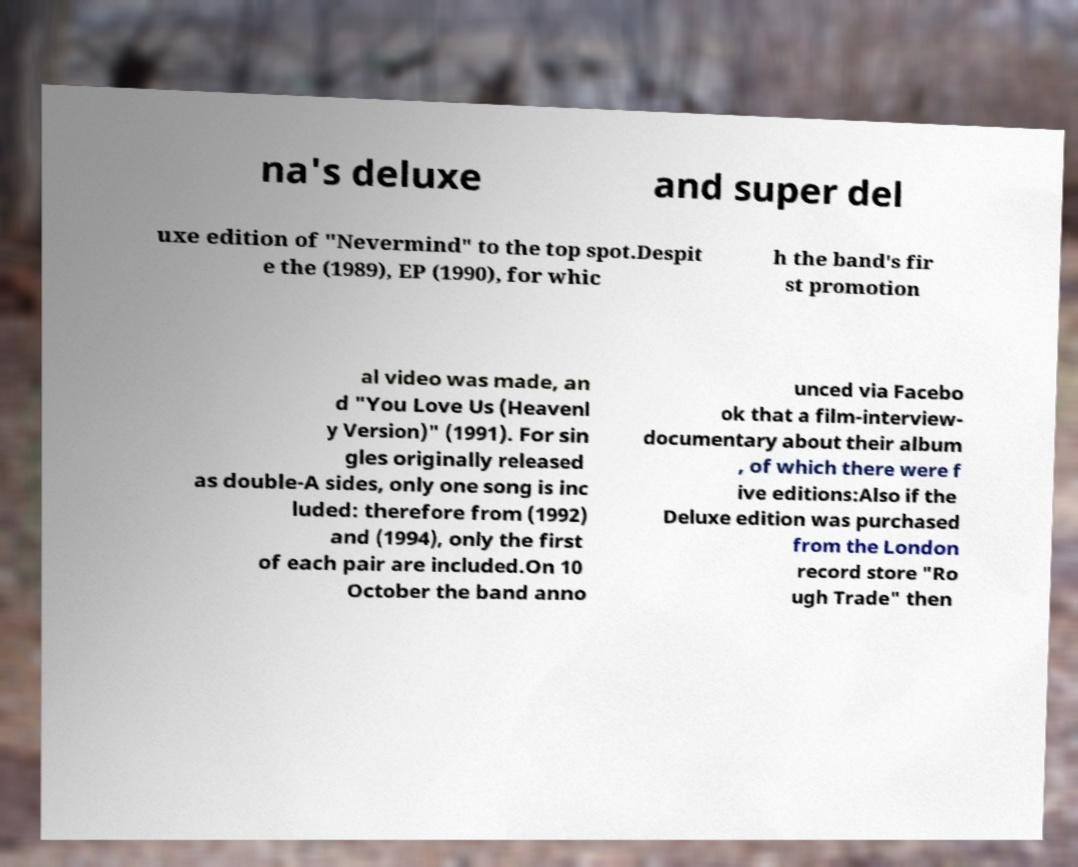For documentation purposes, I need the text within this image transcribed. Could you provide that? na's deluxe and super del uxe edition of "Nevermind" to the top spot.Despit e the (1989), EP (1990), for whic h the band's fir st promotion al video was made, an d "You Love Us (Heavenl y Version)" (1991). For sin gles originally released as double-A sides, only one song is inc luded: therefore from (1992) and (1994), only the first of each pair are included.On 10 October the band anno unced via Facebo ok that a film-interview- documentary about their album , of which there were f ive editions:Also if the Deluxe edition was purchased from the London record store "Ro ugh Trade" then 